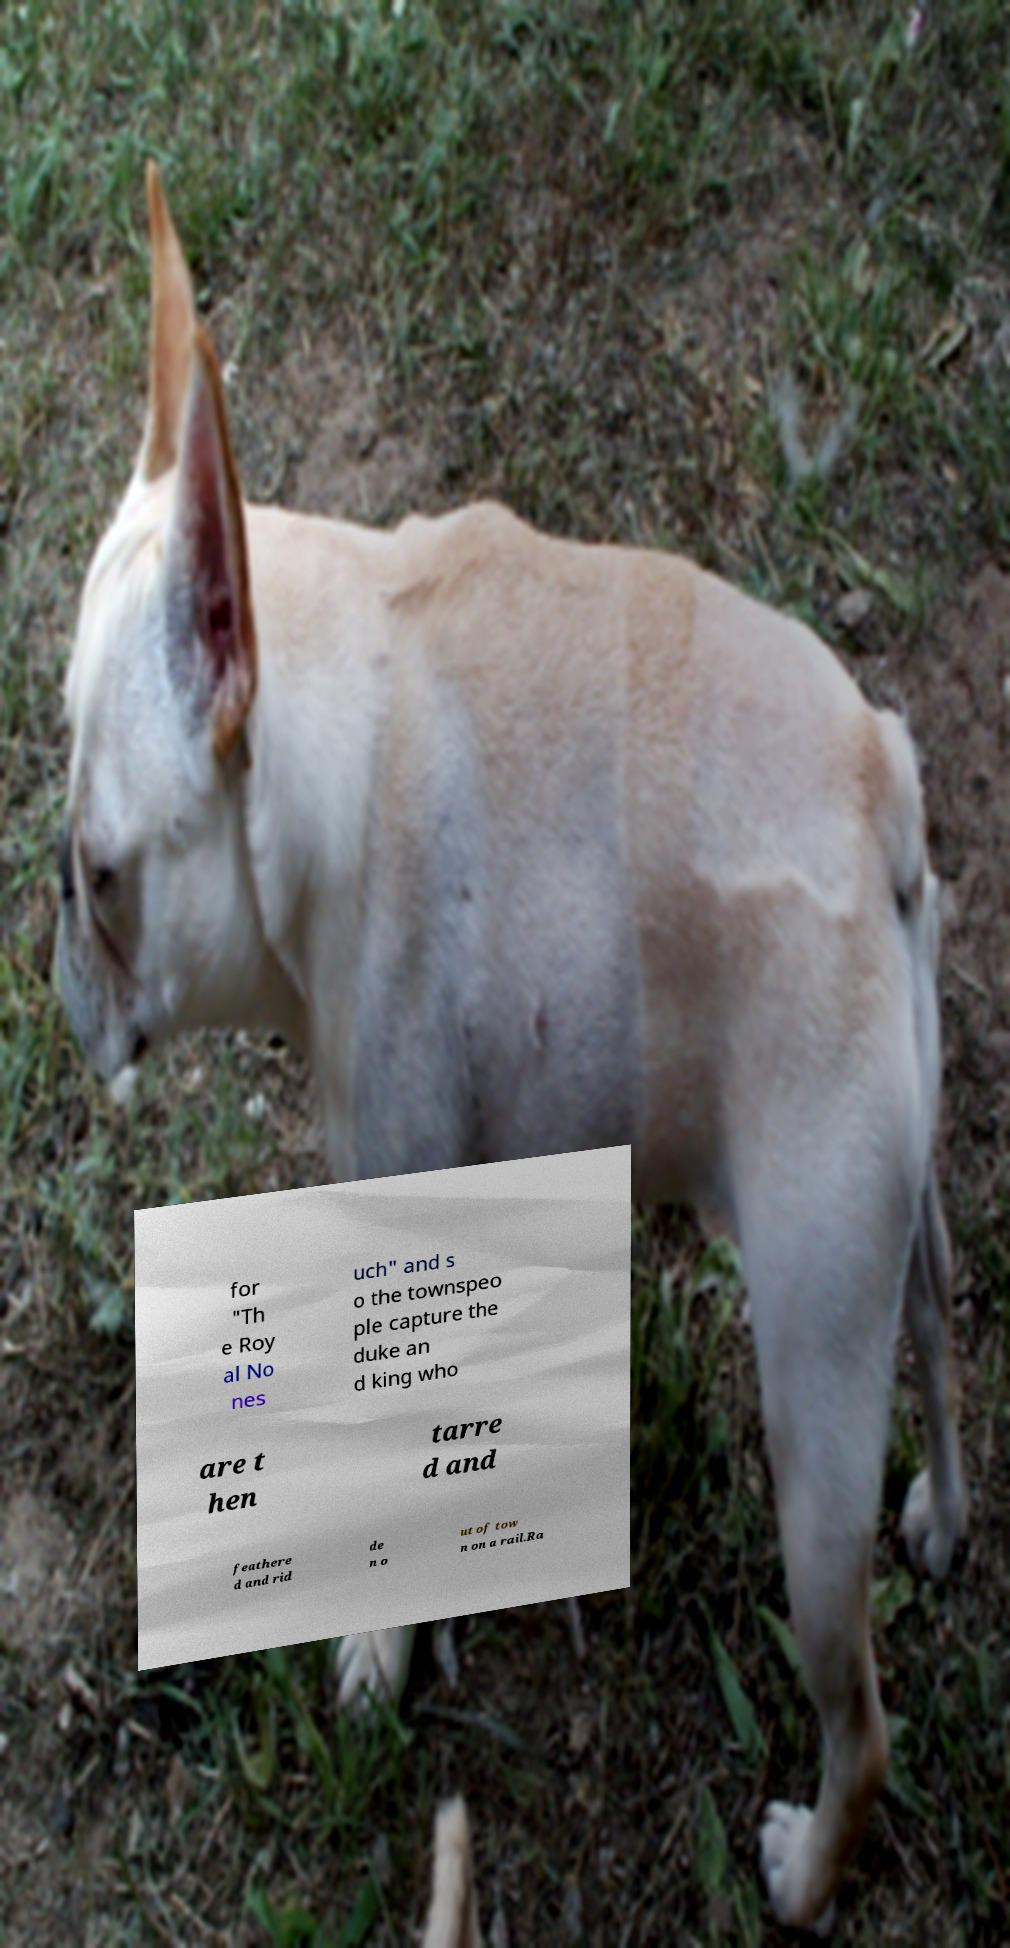What messages or text are displayed in this image? I need them in a readable, typed format. for "Th e Roy al No nes uch" and s o the townspeo ple capture the duke an d king who are t hen tarre d and feathere d and rid de n o ut of tow n on a rail.Ra 